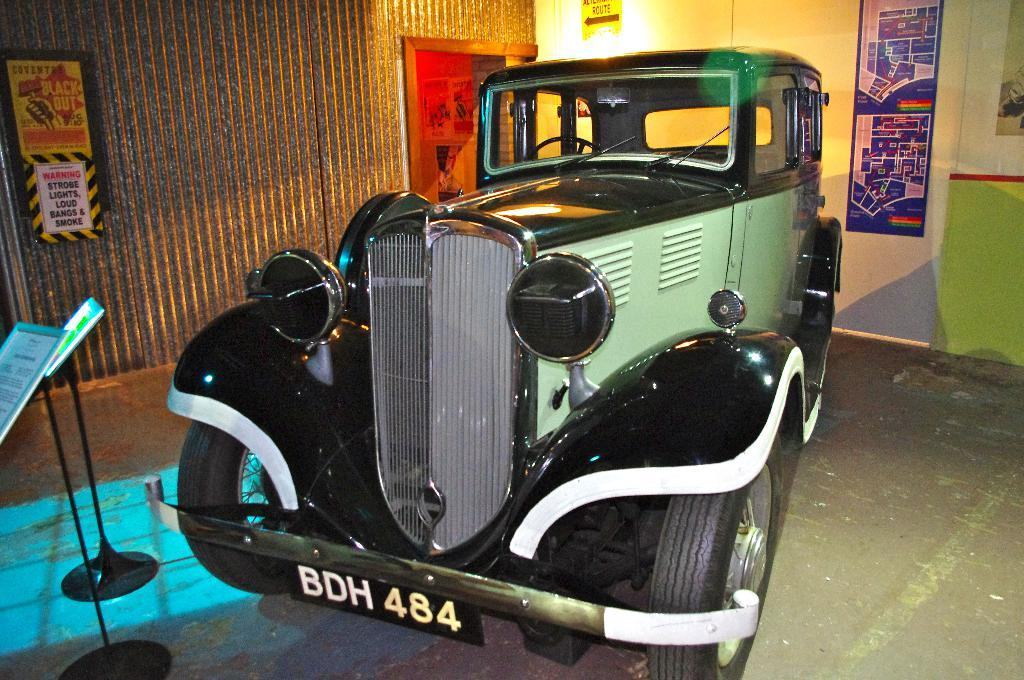What is the main subject in the center of the image? There is a car in the center of the image. What can be seen on the left side of the image? There are posters on the left side of the image. What is located on the right side of the image? There is a map on the right side of the image. What architectural features are visible in the background of the image? There is a door, a light, and a wall in the background of the image. Where is the lunchroom located in the image? There is no mention of a lunchroom in the image; it only features a car, posters, a map, and architectural features in the background. 